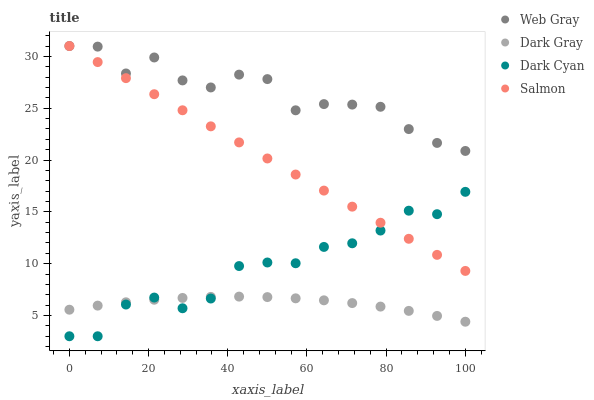Does Dark Gray have the minimum area under the curve?
Answer yes or no. Yes. Does Web Gray have the maximum area under the curve?
Answer yes or no. Yes. Does Dark Cyan have the minimum area under the curve?
Answer yes or no. No. Does Dark Cyan have the maximum area under the curve?
Answer yes or no. No. Is Salmon the smoothest?
Answer yes or no. Yes. Is Web Gray the roughest?
Answer yes or no. Yes. Is Dark Cyan the smoothest?
Answer yes or no. No. Is Dark Cyan the roughest?
Answer yes or no. No. Does Dark Cyan have the lowest value?
Answer yes or no. Yes. Does Web Gray have the lowest value?
Answer yes or no. No. Does Salmon have the highest value?
Answer yes or no. Yes. Does Dark Cyan have the highest value?
Answer yes or no. No. Is Dark Cyan less than Web Gray?
Answer yes or no. Yes. Is Web Gray greater than Dark Gray?
Answer yes or no. Yes. Does Dark Cyan intersect Salmon?
Answer yes or no. Yes. Is Dark Cyan less than Salmon?
Answer yes or no. No. Is Dark Cyan greater than Salmon?
Answer yes or no. No. Does Dark Cyan intersect Web Gray?
Answer yes or no. No. 